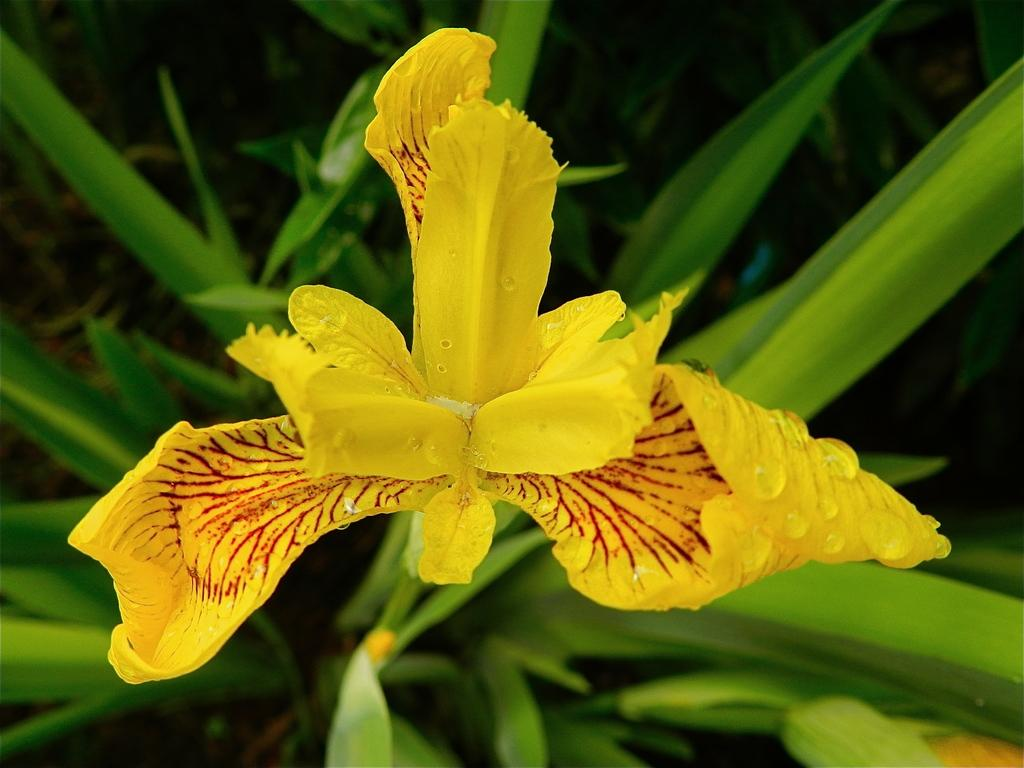What is the main subject of the image? The main subject of the image is a flower. Can you describe the colors of the flower? The flower has yellow and red colors. What is the flower attached to? The flower is attached to a green plant. Are there any additional features on the flower? Yes, there are water droplets on the flower. How many giants are holding the flower in the image? There are no giants present in the image; it features a flower with water droplets on it. What type of marble is used as a decorative element in the image? There is no marble present in the image; it features a flower with water droplets on it. 